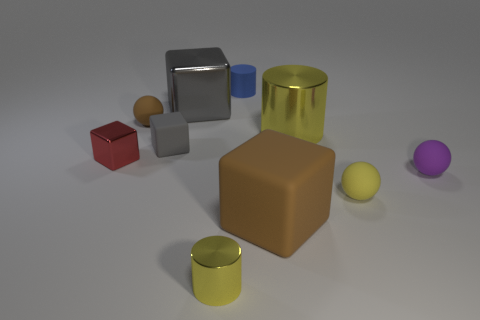There is a brown thing that is left of the large brown matte object; what size is it?
Make the answer very short. Small. There is another small thing that is the same shape as the tiny gray matte object; what is it made of?
Your answer should be very brief. Metal. Is there any other thing that is the same size as the purple rubber object?
Your answer should be compact. Yes. What is the shape of the shiny object that is in front of the purple object?
Your answer should be compact. Cylinder. What number of small purple objects are the same shape as the tiny blue matte thing?
Provide a short and direct response. 0. Are there the same number of tiny purple matte objects that are on the left side of the small red shiny thing and objects on the left side of the gray metal cube?
Provide a short and direct response. No. Is there a blue block made of the same material as the small red block?
Provide a succinct answer. No. Is the tiny brown object made of the same material as the large cylinder?
Provide a succinct answer. No. What number of green objects are either rubber spheres or tiny metal things?
Ensure brevity in your answer.  0. Is the number of gray rubber cubes to the left of the tiny red metallic thing greater than the number of large brown rubber cubes?
Give a very brief answer. No. 